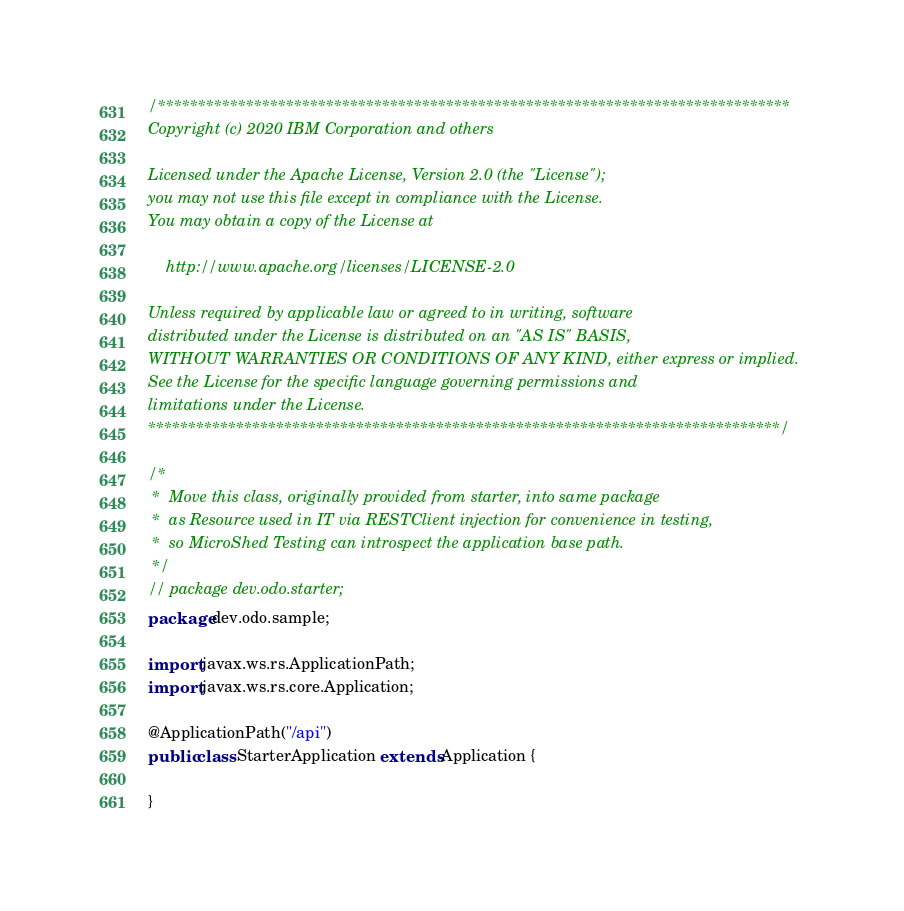Convert code to text. <code><loc_0><loc_0><loc_500><loc_500><_Java_>/*******************************************************************************
Copyright (c) 2020 IBM Corporation and others

Licensed under the Apache License, Version 2.0 (the "License");
you may not use this file except in compliance with the License.
You may obtain a copy of the License at

    http://www.apache.org/licenses/LICENSE-2.0

Unless required by applicable law or agreed to in writing, software
distributed under the License is distributed on an "AS IS" BASIS,
WITHOUT WARRANTIES OR CONDITIONS OF ANY KIND, either express or implied.
See the License for the specific language governing permissions and
limitations under the License.
*******************************************************************************/

/*
 *  Move this class, originally provided from starter, into same package 
 *  as Resource used in IT via RESTClient injection for convenience in testing, 
 *  so MicroShed Testing can introspect the application base path.
 */
// package dev.odo.starter;
package dev.odo.sample;

import javax.ws.rs.ApplicationPath;
import javax.ws.rs.core.Application;

@ApplicationPath("/api")
public class StarterApplication extends Application {

}
</code> 